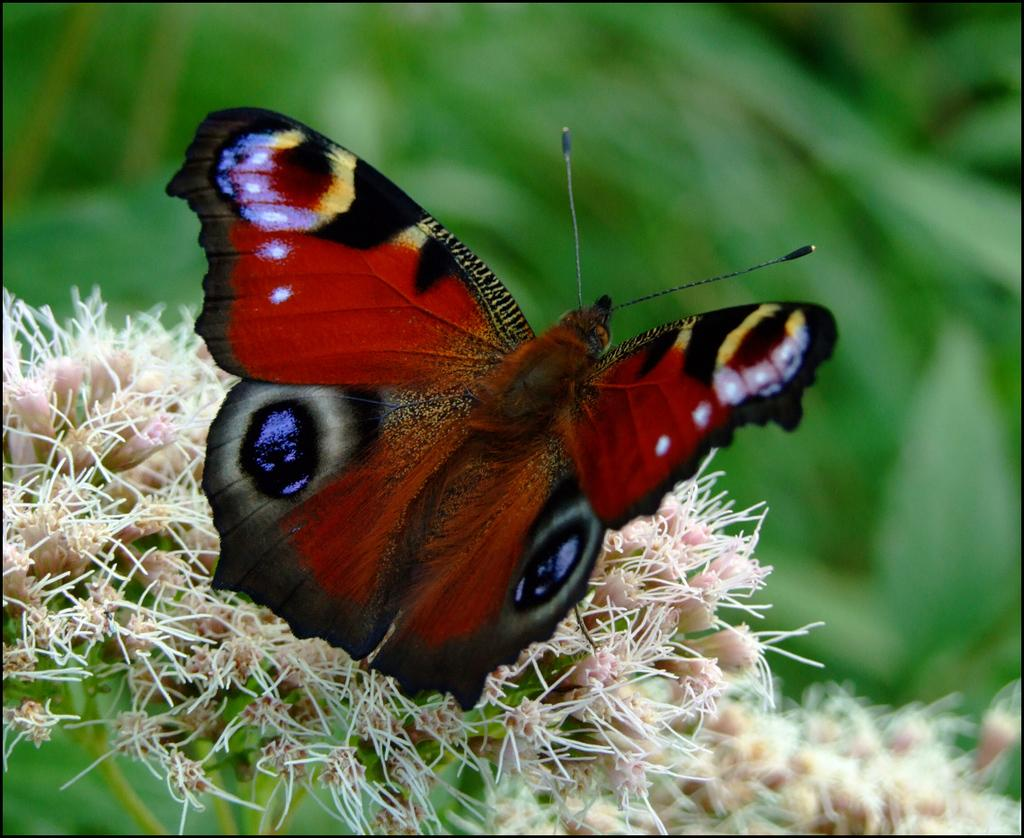What is the main subject of the image? There is a butterfly in the image. Where is the butterfly located in the image? The butterfly is sitting on a flower. Can you describe the background of the image? The background of the image is blurred. What type of screw can be seen holding the pickle on the stage in the image? There is no screw, pickle, or stage present in the image; it features a butterfly sitting on a flower with a blurred background. 